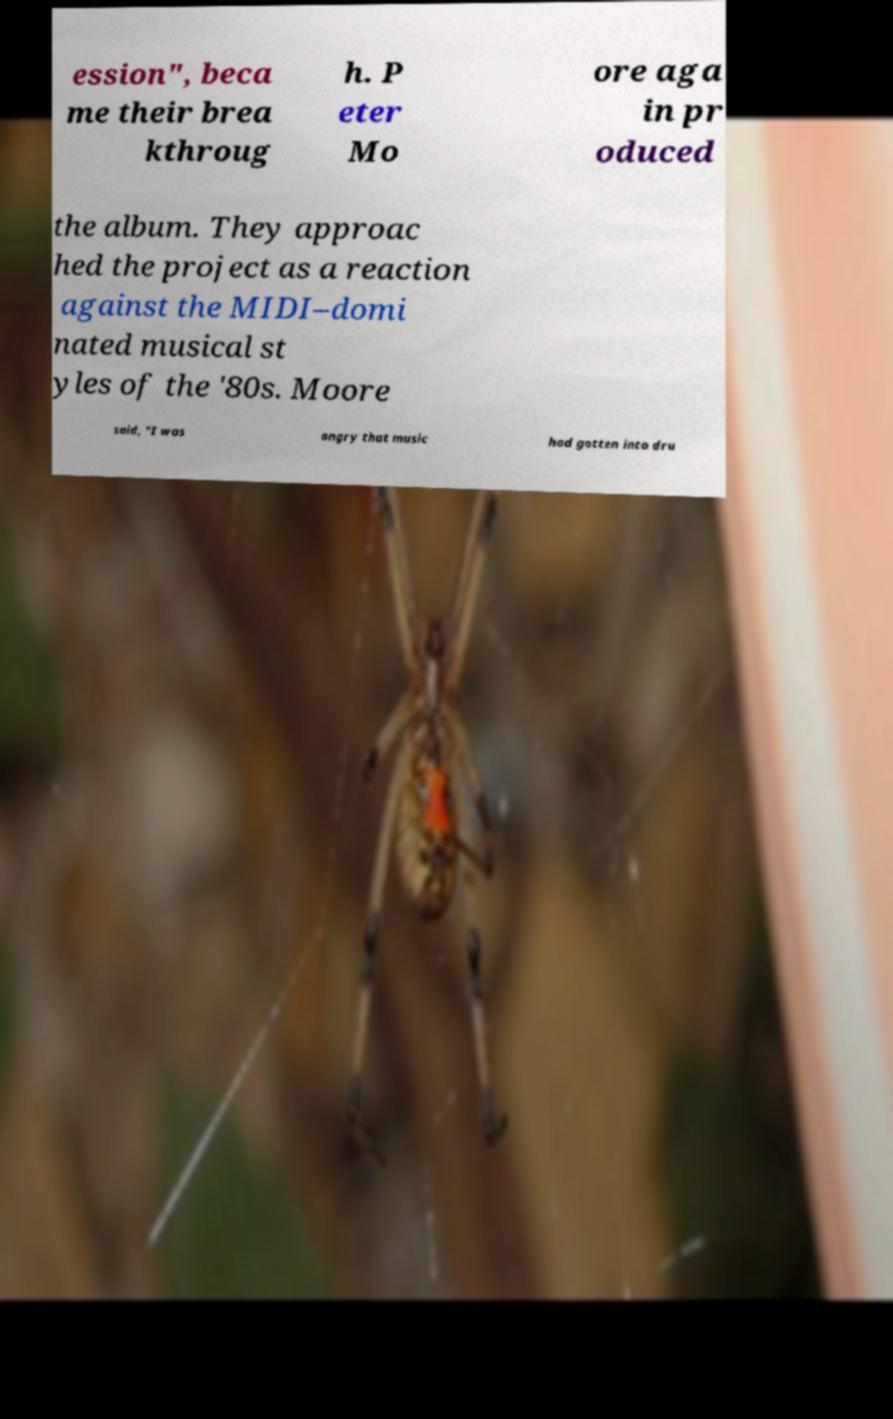What messages or text are displayed in this image? I need them in a readable, typed format. ession", beca me their brea kthroug h. P eter Mo ore aga in pr oduced the album. They approac hed the project as a reaction against the MIDI–domi nated musical st yles of the '80s. Moore said, "I was angry that music had gotten into dru 